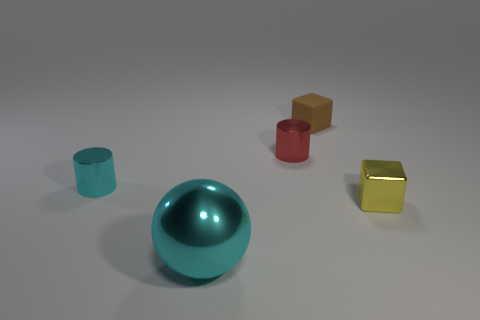Are there any other things that have the same shape as the large object?
Make the answer very short. No. What color is the shiny cylinder behind the cyan shiny thing that is behind the tiny metal thing that is right of the matte cube?
Offer a very short reply. Red. Is there anything else that has the same size as the metal ball?
Offer a very short reply. No. There is a large metal object; is its color the same as the tiny metal object on the left side of the red cylinder?
Offer a very short reply. Yes. The metal cube has what color?
Provide a short and direct response. Yellow. There is a small metallic thing on the left side of the cylinder that is behind the metal thing to the left of the large shiny sphere; what shape is it?
Make the answer very short. Cylinder. How many other objects are there of the same color as the large metallic object?
Keep it short and to the point. 1. Is the number of yellow metal blocks in front of the tiny cyan metal object greater than the number of tiny red metal things behind the brown rubber block?
Give a very brief answer. Yes. There is a large cyan object; are there any tiny red shiny objects behind it?
Give a very brief answer. Yes. What is the material of the object that is both in front of the cyan metallic cylinder and to the right of the big cyan shiny sphere?
Provide a short and direct response. Metal. 